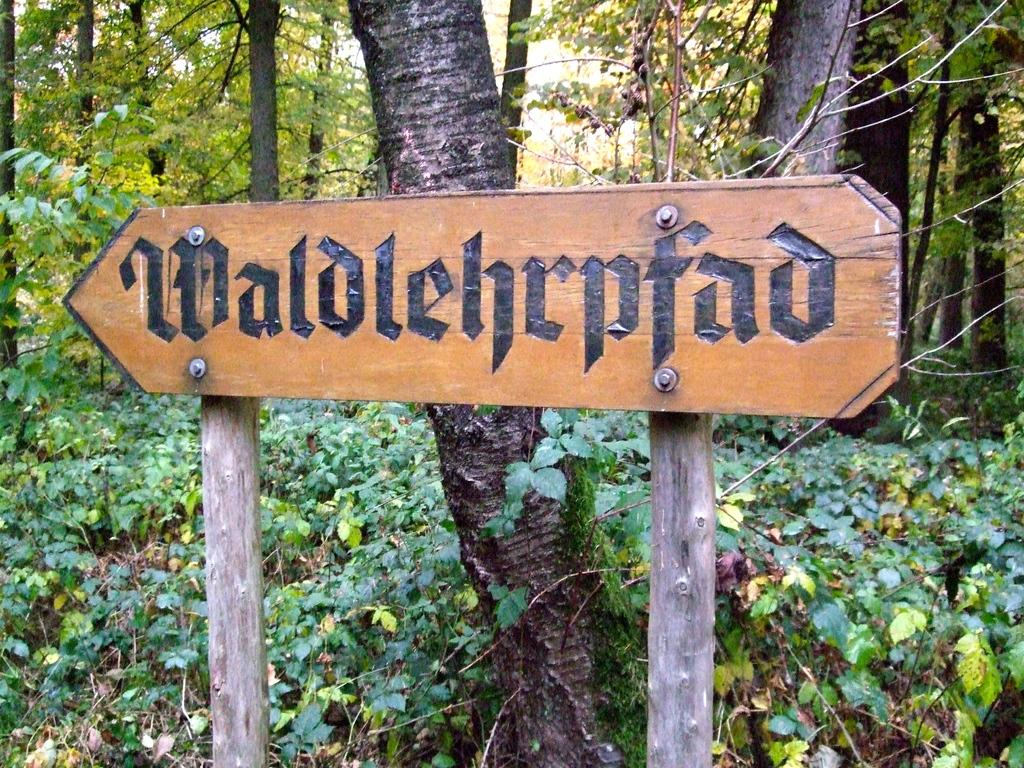What is the main structure in the image? There is a board on poles in the image. What can be seen written on the board? Names are written on the board. What type of vegetation is visible behind the board? There are plants and trees visible behind the board. What type of hair can be seen on the rabbit in the image? There is no rabbit present in the image, and therefore no hair can be observed. Who is the creator of the board in the image? The facts provided do not mention the creator of the board, so it cannot be determined from the image. 